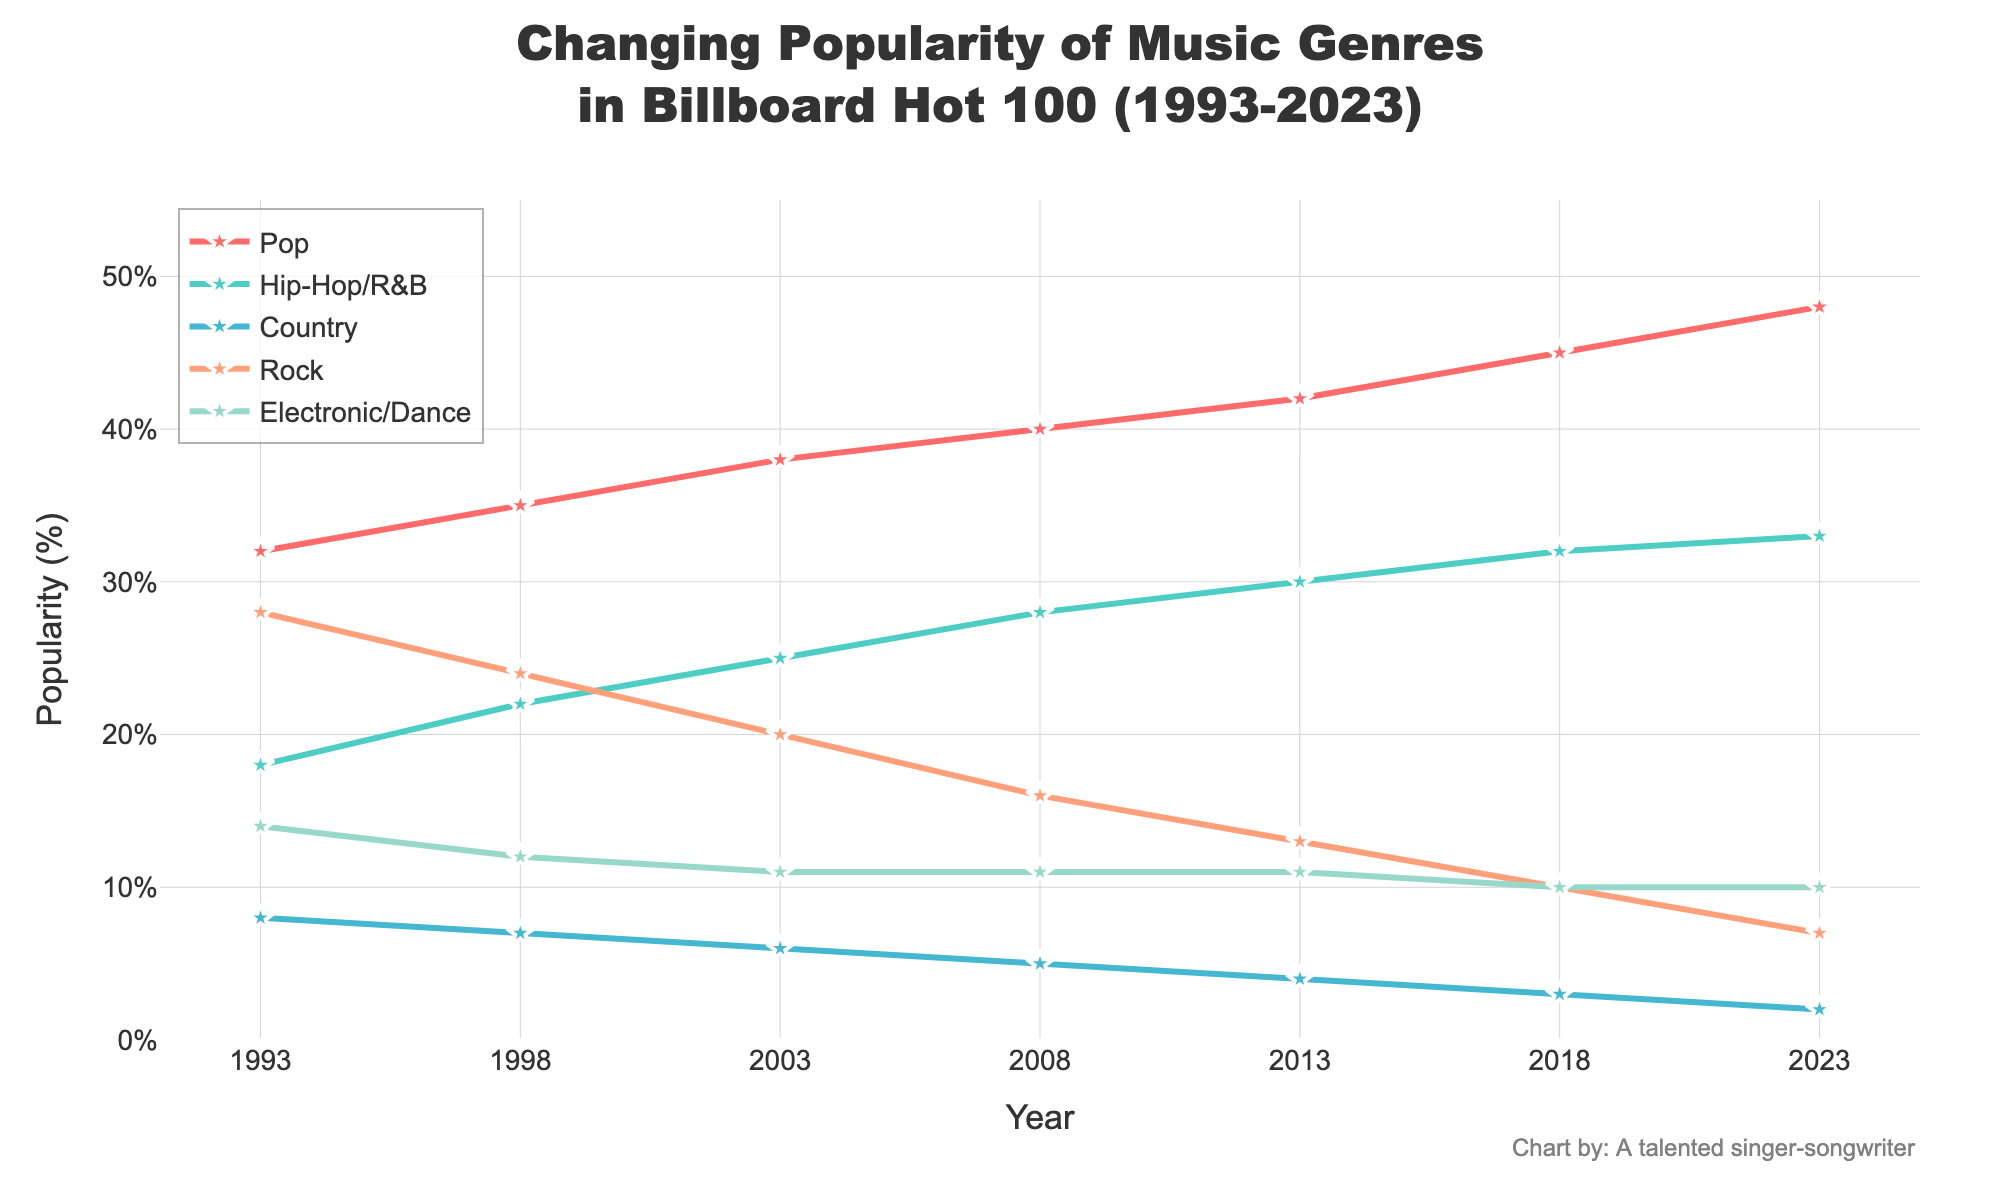Which genre had the highest popularity in 2023? Look for the highest line in 2023. Pop leads with a value of 48%.
Answer: Pop How much did the popularity of Rock decrease from 1993 to 2023? Identify the popularity of Rock in 1993 (28%) and in 2023 (7%). Calculate the decrease: 28% - 7% = 21%.
Answer: 21% Which genre showed a constant percentage of popularity from 2008 onwards? Trace the lines and find the genre that remains unchanged from 2008 to 2023. Electronic/Dance has remained at 11%, then 10% in 2018 and 2023.
Answer: Electronic/Dance What is the total percentage of Hip-Hop/R&B popularity across all years shown? Sum up the values for Hip-Hop/R&B over the given years: 18 + 22 + 25 + 28 + 30 + 32 + 33 = 188%.
Answer: 188% Which genre had the steepest increase in popularity from 1993 to 2023? Compare the differences for each genre between 1993 and 2023. Pop goes from 32% to 48%, an increase of 16%, which is the steepest compared to other genres.
Answer: Pop How did the popularity of Country music change from 1993 to 2023? Check the values for Country in 1993 (8%) and in 2023 (2%). The change is 8% - 2% = -6%.
Answer: -6% By how much did the popularity of Hip-Hop/R&B surpass Rock in 2013? Find popularity for Hip-Hop/R&B (30%) and Rock (13%) in 2013. Calculate the difference: 30% - 13% = 17%.
Answer: 17% Which genre's popularity remained the least in 2023 and what was its value? Find the lowest point on the graph in 2023. Country is the least popular with 2%.
Answer: Country, 2% Between which years did the genre Pop remain at its most constant state? Observe the line for Pop for flat segments. From 2008 (40%) to 2013 (42%) would be the most constant state.
Answer: 2008 to 2013 What is the cumulative popularity of Pop and Rock in 1993? Sum the percentages of Pop (32%) and Rock (28%) in 1993: 32% + 28% = 60%.
Answer: 60% 